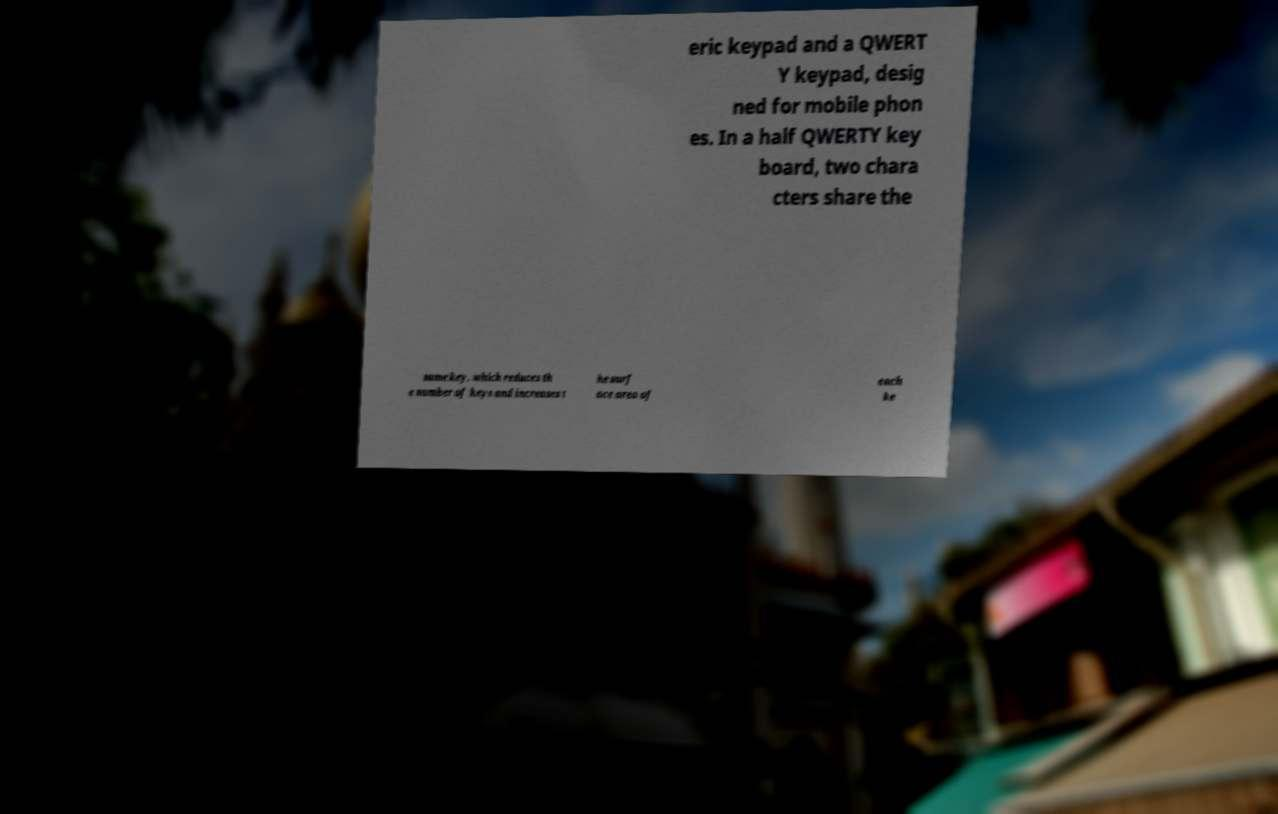Could you extract and type out the text from this image? eric keypad and a QWERT Y keypad, desig ned for mobile phon es. In a half QWERTY key board, two chara cters share the same key, which reduces th e number of keys and increases t he surf ace area of each ke 